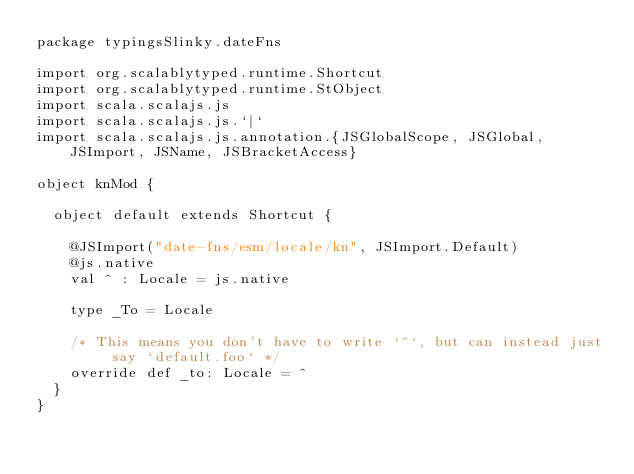<code> <loc_0><loc_0><loc_500><loc_500><_Scala_>package typingsSlinky.dateFns

import org.scalablytyped.runtime.Shortcut
import org.scalablytyped.runtime.StObject
import scala.scalajs.js
import scala.scalajs.js.`|`
import scala.scalajs.js.annotation.{JSGlobalScope, JSGlobal, JSImport, JSName, JSBracketAccess}

object knMod {
  
  object default extends Shortcut {
    
    @JSImport("date-fns/esm/locale/kn", JSImport.Default)
    @js.native
    val ^ : Locale = js.native
    
    type _To = Locale
    
    /* This means you don't have to write `^`, but can instead just say `default.foo` */
    override def _to: Locale = ^
  }
}
</code> 